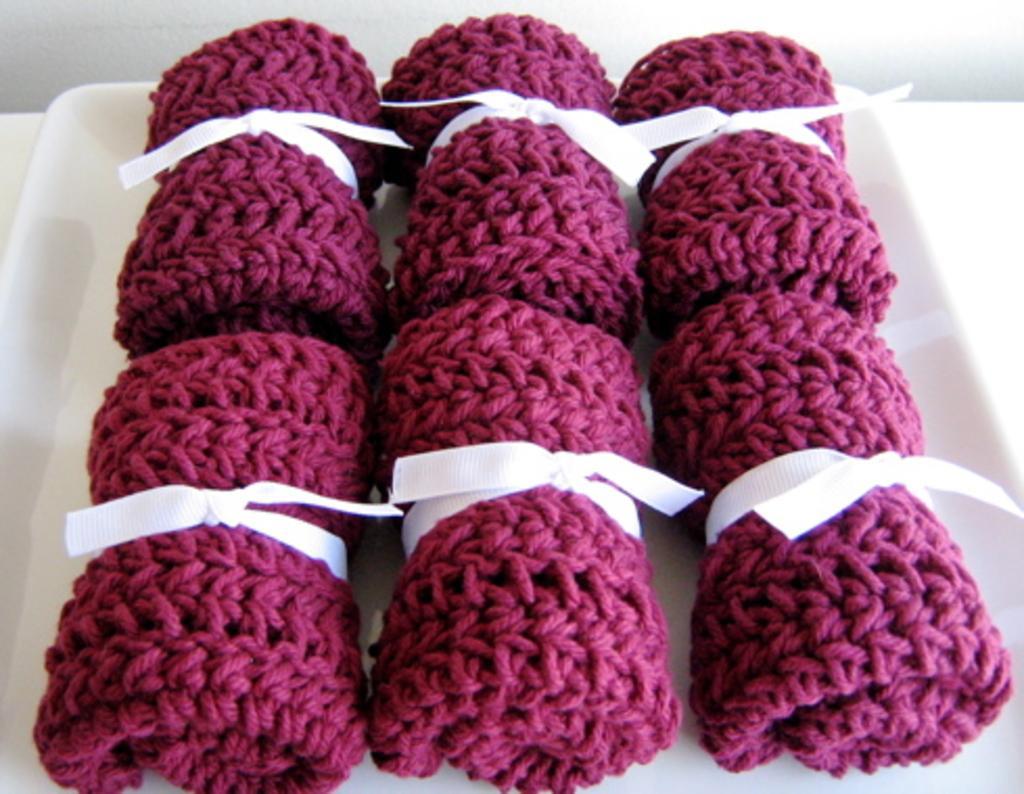Can you describe this image briefly? In this picture we can see few crochets in the plate. 